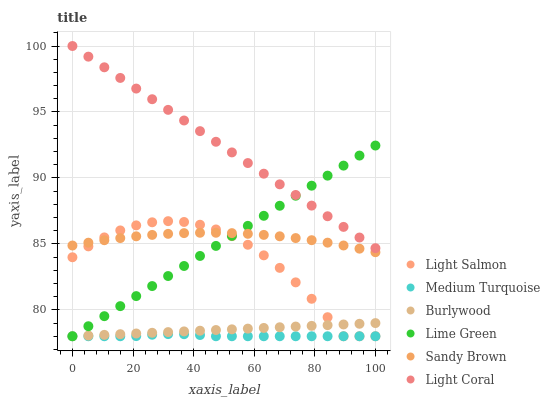Does Medium Turquoise have the minimum area under the curve?
Answer yes or no. Yes. Does Light Coral have the maximum area under the curve?
Answer yes or no. Yes. Does Burlywood have the minimum area under the curve?
Answer yes or no. No. Does Burlywood have the maximum area under the curve?
Answer yes or no. No. Is Burlywood the smoothest?
Answer yes or no. Yes. Is Light Salmon the roughest?
Answer yes or no. Yes. Is Lime Green the smoothest?
Answer yes or no. No. Is Lime Green the roughest?
Answer yes or no. No. Does Light Salmon have the lowest value?
Answer yes or no. Yes. Does Light Coral have the lowest value?
Answer yes or no. No. Does Light Coral have the highest value?
Answer yes or no. Yes. Does Burlywood have the highest value?
Answer yes or no. No. Is Light Salmon less than Light Coral?
Answer yes or no. Yes. Is Light Coral greater than Sandy Brown?
Answer yes or no. Yes. Does Medium Turquoise intersect Lime Green?
Answer yes or no. Yes. Is Medium Turquoise less than Lime Green?
Answer yes or no. No. Is Medium Turquoise greater than Lime Green?
Answer yes or no. No. Does Light Salmon intersect Light Coral?
Answer yes or no. No. 